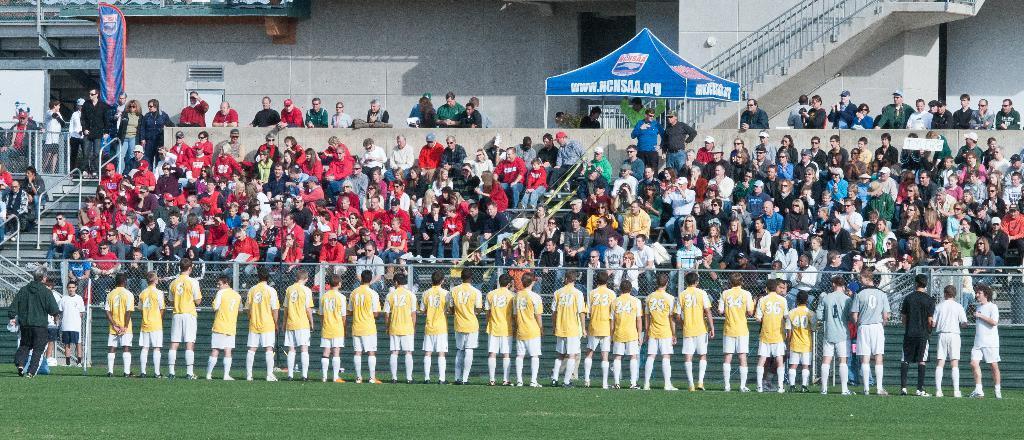Can you describe this image briefly? In this image in the front there is grass on the ground in the center there are persons standing and there is a fence. In the background there are persons sitting and standing and there is a tent with some text written on it which is blue in colour and there is a wall, there is a staircase and on the left side there is a banner with some text written on it. 